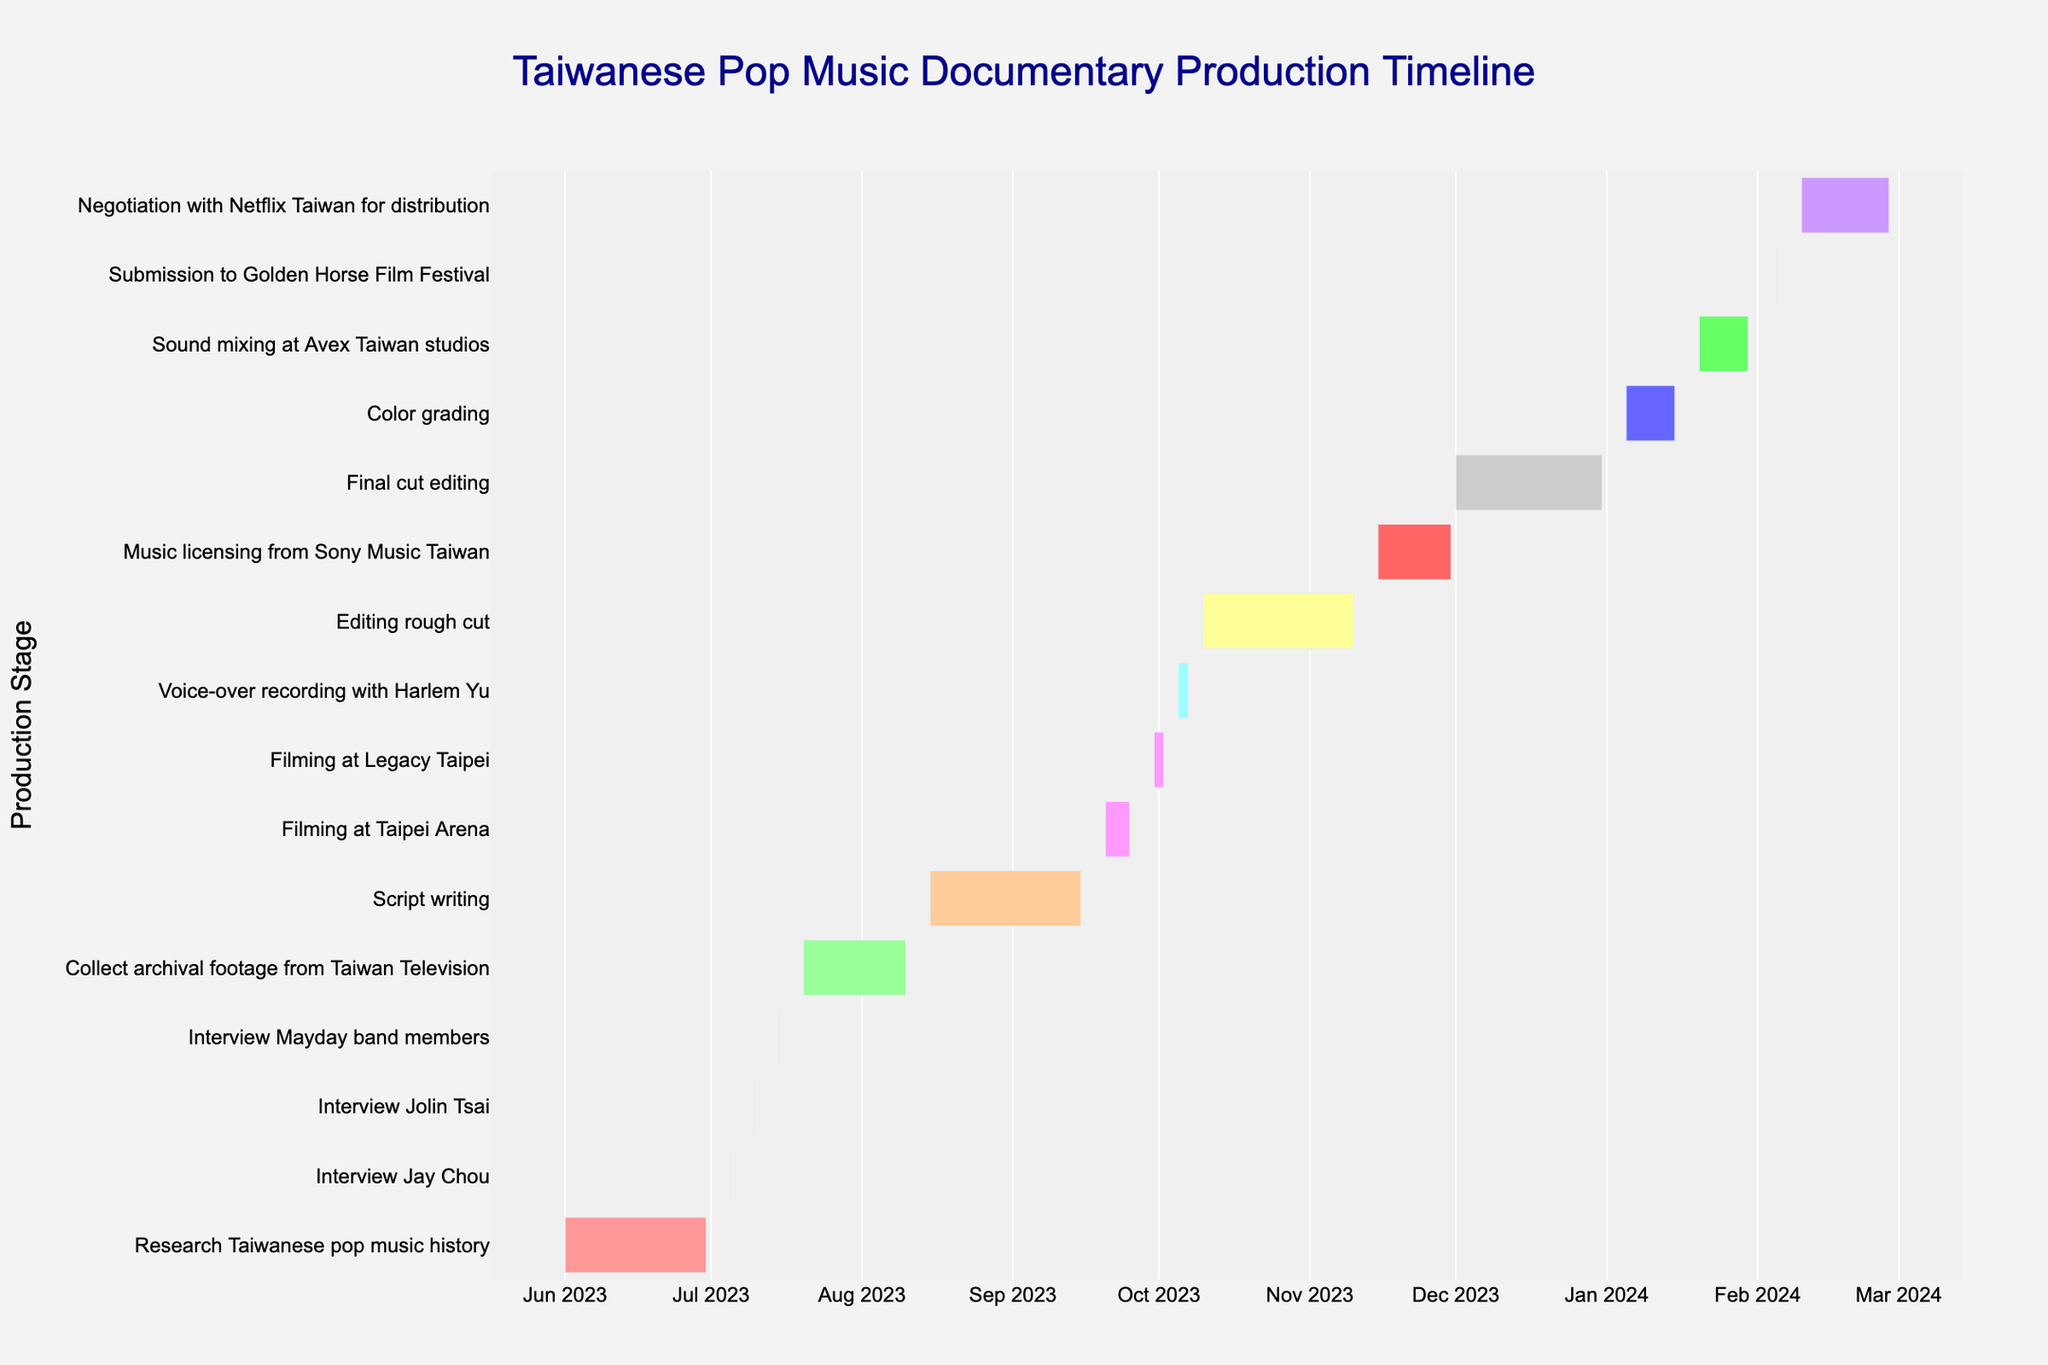When does the script writing process begin? To find out when the script writing starts, look at the task labeled "Script writing" and identify the start date on the timeline.
Answer: August 15, 2023 Which task has the shortest duration? Identify all tasks on the timeline and find the one with the shortest bar, indicating it has the minimum duration. "Interview Jay Chou," "Interview Jolin Tsai," "Interview Mayday band members," and "Submission to Golden Horse Film Festival" all have the shortest duration.
Answer: Interview Jay Chou / Interview Jolin Tsai / Interview Mayday band members / Submission to Golden Horse Film Festival How long is the filming at Legacy Taipei scheduled to last? Look at the "Filming at Legacy Taipei" bar to see the start and end dates on the timeline. The duration can be calculated as the difference between these dates.
Answer: 3 days What is the total duration for collecting archival footage and script writing combined? To find the total duration, sum the individual durations of "Collect archival footage from Taiwan Television" and "Script writing."
Answer: 22 + 32 = 54 days Which filming location is scheduled to be used first? Compare the start dates of "Filming at Taipei Arena" and "Filming at Legacy Taipei" to see which one comes first on the timeline.
Answer: Taipei Arena Does any task end in December 2023? If so, which one? Check the timeline for tasks that have end dates within December 2023, particularly the final cut editing task.
Answer: Final cut editing When does the color grading task end? Check the timeline for the "Color grading" task to identify the end date marked on the timeline.
Answer: January 15, 2024 Which comes first: completing the rough cut editing or starting music licensing? Compare the end date of "Editing rough cut" with the start date of "Music licensing from Sony Music Taiwan" on the timeline.
Answer: Completing the rough cut editing What is the next task after voice-over recording with Harlem Yu? On the timeline, locate the end date of "Voice-over recording with Harlem Yu" and see which task starts immediately afterward.
Answer: Editing rough cut Which task has the longest duration and how many days is it? Identify the longest bar on the timeline, indicating the task with the maximum duration. "Script writing" and "Editing rough cut" both have the longest duration bars.
Answer: Script writing / Editing rough cut (32 days each) 